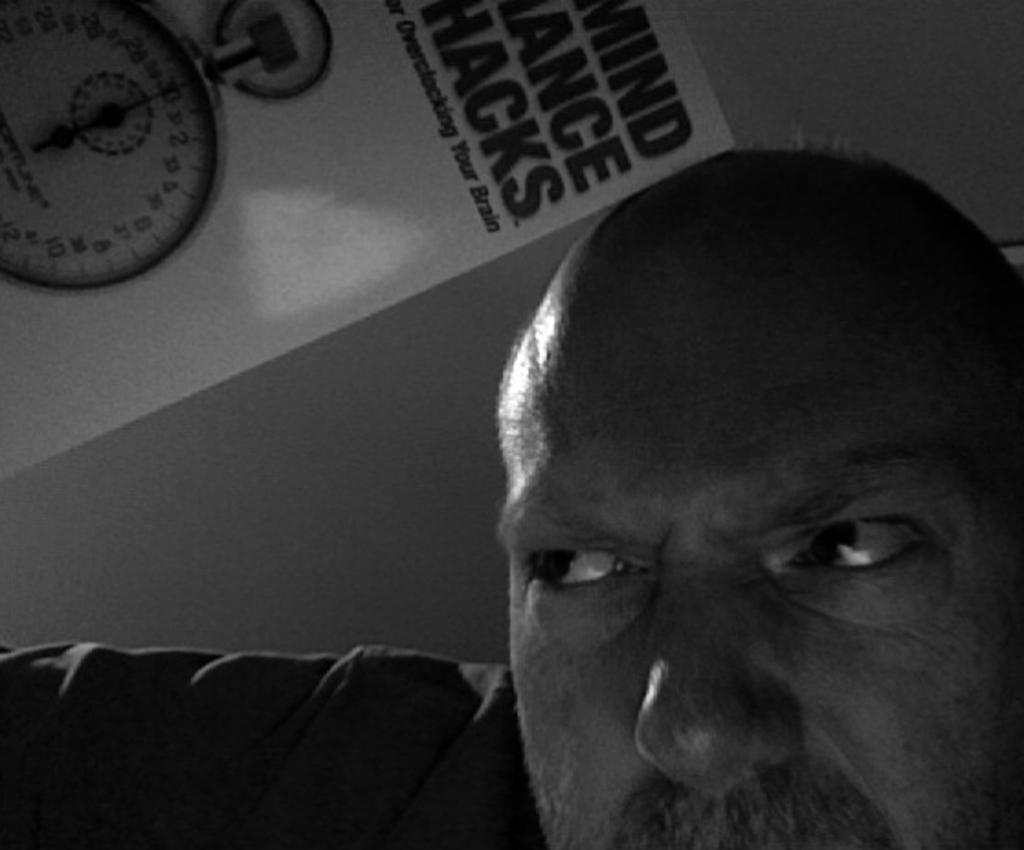What is the color scheme of the image? The image is black and white. Can you describe the main subject in the image? There is a person in the image. What else can be seen in the background of the image? There is a sticker in the background of the image. What is depicted on the sticker? The sticker has a meter on it. How many nuts are hanging from the bells in the image? There are no bells or nuts present in the image. What type of loss is depicted in the image? There is no loss depicted in the image; it features a person, a black and white color scheme, and a sticker with a meter. 